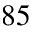Convert formula to latex. <formula><loc_0><loc_0><loc_500><loc_500>^ { 8 5 }</formula> 